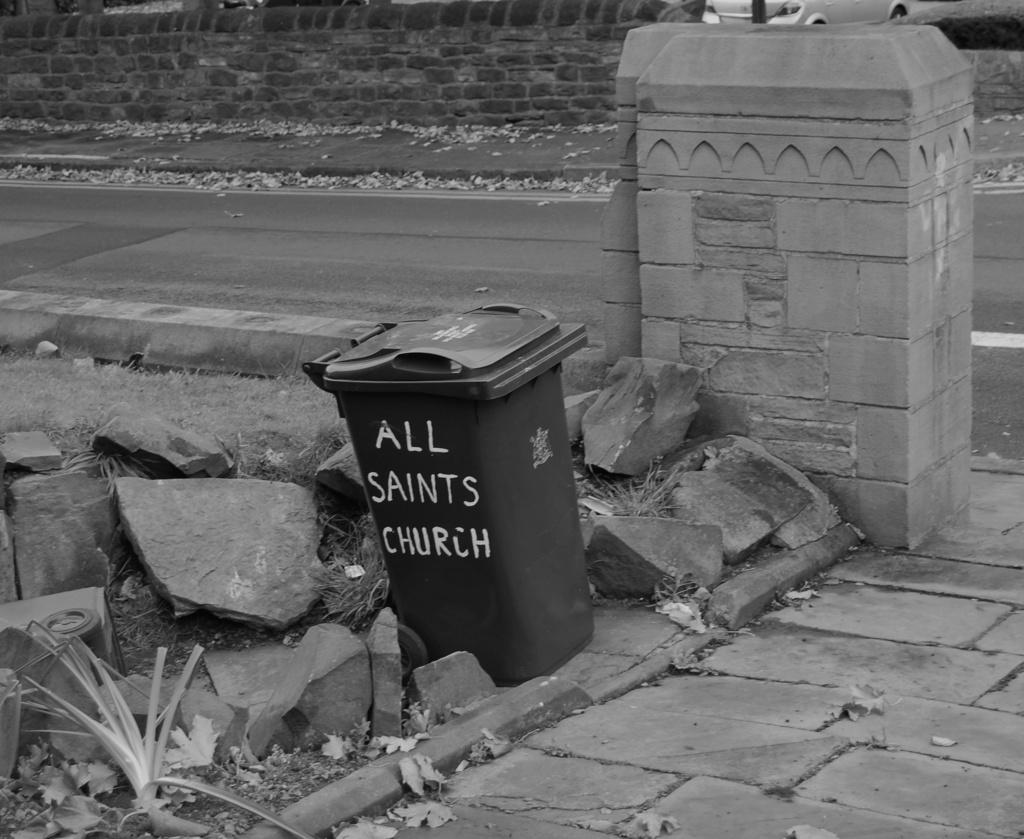What object can be seen in the image for disposing of waste? There is a dustbin in the image. What type of natural elements can be seen in the background of the image? There are stones visible in the background of the image. What type of man-made object can be seen in the background of the image? There is a vehicle in the background of the image. How is the image presented in terms of color? The image is in black and white. What type of plants can be seen coughing in the image? There are no plants or instances of coughing present in the image. 